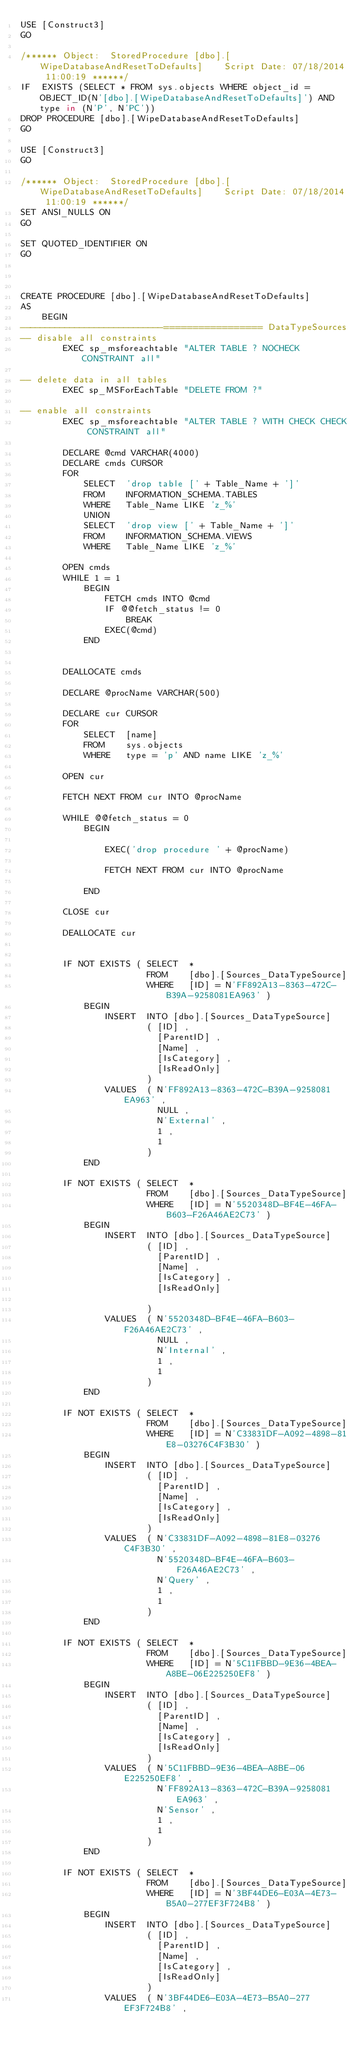Convert code to text. <code><loc_0><loc_0><loc_500><loc_500><_SQL_>USE [Construct3]
GO

/****** Object:  StoredProcedure [dbo].[WipeDatabaseAndResetToDefaults]    Script Date: 07/18/2014 11:00:19 ******/
IF  EXISTS (SELECT * FROM sys.objects WHERE object_id = OBJECT_ID(N'[dbo].[WipeDatabaseAndResetToDefaults]') AND type in (N'P', N'PC'))
DROP PROCEDURE [dbo].[WipeDatabaseAndResetToDefaults]
GO

USE [Construct3]
GO

/****** Object:  StoredProcedure [dbo].[WipeDatabaseAndResetToDefaults]    Script Date: 07/18/2014 11:00:19 ******/
SET ANSI_NULLS ON
GO

SET QUOTED_IDENTIFIER ON
GO



CREATE PROCEDURE [dbo].[WipeDatabaseAndResetToDefaults]
AS 
    BEGIN
-----------------------------================= DataTypeSources
-- disable all constraints
        EXEC sp_msforeachtable "ALTER TABLE ? NOCHECK CONSTRAINT all"

-- delete data in all tables
        EXEC sp_MSForEachTable "DELETE FROM ?"

-- enable all constraints
        EXEC sp_msforeachtable "ALTER TABLE ? WITH CHECK CHECK CONSTRAINT all"

        DECLARE @cmd VARCHAR(4000)
        DECLARE cmds CURSOR
        FOR
            SELECT  'drop table [' + Table_Name + ']'
            FROM    INFORMATION_SCHEMA.TABLES
            WHERE   Table_Name LIKE 'z_%'
            UNION
            SELECT  'drop view [' + Table_Name + ']'
            FROM    INFORMATION_SCHEMA.VIEWS
            WHERE   Table_Name LIKE 'z_%'
    
        OPEN cmds
        WHILE 1 = 1 
            BEGIN
                FETCH cmds INTO @cmd
                IF @@fetch_status != 0 
                    BREAK
                EXEC(@cmd)
            END
    

        DEALLOCATE cmds

        DECLARE @procName VARCHAR(500)
 
        DECLARE cur CURSOR
        FOR
            SELECT  [name]
            FROM    sys.objects
            WHERE   type = 'p' AND name LIKE 'z_%'
 
        OPEN cur

        FETCH NEXT FROM cur INTO @procName
 
        WHILE @@fetch_status = 0 
            BEGIN
 
                EXEC('drop procedure ' + @procName)
 
                FETCH NEXT FROM cur INTO @procName
 
            END
 
        CLOSE cur
 
        DEALLOCATE cur

    
        IF NOT EXISTS ( SELECT  *
                        FROM    [dbo].[Sources_DataTypeSource]
                        WHERE   [ID] = N'FF892A13-8363-472C-B39A-9258081EA963' ) 
            BEGIN
                INSERT  INTO [dbo].[Sources_DataTypeSource]
                        ( [ID] ,
                          [ParentID] ,
                          [Name] ,
                          [IsCategory] ,
                          [IsReadOnly]
                        )
                VALUES  ( N'FF892A13-8363-472C-B39A-9258081EA963' ,
                          NULL ,
                          N'External' ,
                          1 ,
                          1
                        )
            END
	
        IF NOT EXISTS ( SELECT  *
                        FROM    [dbo].[Sources_DataTypeSource]
                        WHERE   [ID] = N'5520348D-BF4E-46FA-B603-F26A46AE2C73' ) 
            BEGIN
                INSERT  INTO [dbo].[Sources_DataTypeSource]
                        ( [ID] ,
                          [ParentID] ,
                          [Name] ,
                          [IsCategory] ,
                          [IsReadOnly]
                  
                        )
                VALUES  ( N'5520348D-BF4E-46FA-B603-F26A46AE2C73' ,
                          NULL ,
                          N'Internal' ,
                          1 ,
                          1
                        )
            END
		
        IF NOT EXISTS ( SELECT  *
                        FROM    [dbo].[Sources_DataTypeSource]
                        WHERE   [ID] = N'C33831DF-A092-4898-81E8-03276C4F3B30' ) 
            BEGIN
                INSERT  INTO [dbo].[Sources_DataTypeSource]
                        ( [ID] ,
                          [ParentID] ,
                          [Name] ,
                          [IsCategory] ,
                          [IsReadOnly]
                        )
                VALUES  ( N'C33831DF-A092-4898-81E8-03276C4F3B30' ,
                          N'5520348D-BF4E-46FA-B603-F26A46AE2C73' ,
                          N'Query' ,
                          1 ,
                          1
                        )
            END
	
        IF NOT EXISTS ( SELECT  *
                        FROM    [dbo].[Sources_DataTypeSource]
                        WHERE   [ID] = N'5C11FBBD-9E36-4BEA-A8BE-06E225250EF8' ) 
            BEGIN
                INSERT  INTO [dbo].[Sources_DataTypeSource]
                        ( [ID] ,
                          [ParentID] ,
                          [Name] ,
                          [IsCategory] ,
                          [IsReadOnly]
                        )
                VALUES  ( N'5C11FBBD-9E36-4BEA-A8BE-06E225250EF8' ,
                          N'FF892A13-8363-472C-B39A-9258081EA963' ,
                          N'Sensor' ,
                          1 ,
                          1
                        )
            END	
	
        IF NOT EXISTS ( SELECT  *
                        FROM    [dbo].[Sources_DataTypeSource]
                        WHERE   [ID] = N'3BF44DE6-E03A-4E73-B5A0-277EF3F724B8' ) 
            BEGIN
                INSERT  INTO [dbo].[Sources_DataTypeSource]
                        ( [ID] ,
                          [ParentID] ,
                          [Name] ,
                          [IsCategory] ,
                          [IsReadOnly]
                        )
                VALUES  ( N'3BF44DE6-E03A-4E73-B5A0-277EF3F724B8' ,</code> 